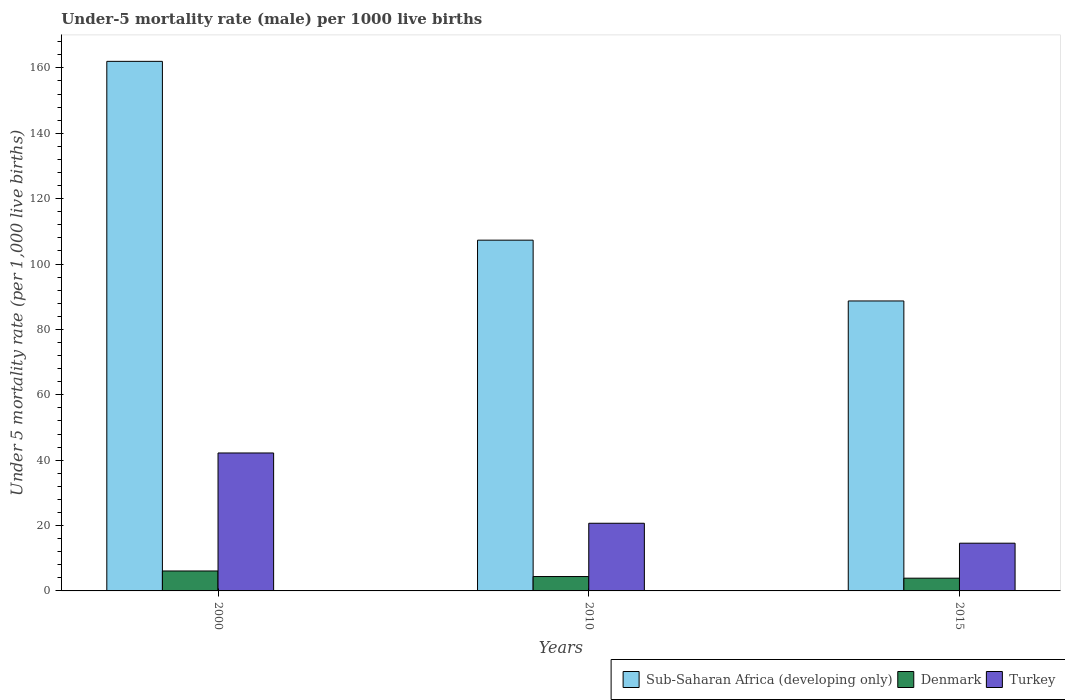How many different coloured bars are there?
Offer a very short reply. 3. How many groups of bars are there?
Provide a short and direct response. 3. Are the number of bars on each tick of the X-axis equal?
Provide a succinct answer. Yes. How many bars are there on the 3rd tick from the right?
Give a very brief answer. 3. Across all years, what is the maximum under-five mortality rate in Sub-Saharan Africa (developing only)?
Your response must be concise. 162. In which year was the under-five mortality rate in Sub-Saharan Africa (developing only) minimum?
Ensure brevity in your answer.  2015. What is the total under-five mortality rate in Sub-Saharan Africa (developing only) in the graph?
Make the answer very short. 358. What is the difference between the under-five mortality rate in Sub-Saharan Africa (developing only) in 2000 and that in 2010?
Make the answer very short. 54.7. What is the difference between the under-five mortality rate in Turkey in 2010 and the under-five mortality rate in Denmark in 2015?
Make the answer very short. 16.8. What is the average under-five mortality rate in Sub-Saharan Africa (developing only) per year?
Your answer should be compact. 119.33. In the year 2015, what is the difference between the under-five mortality rate in Denmark and under-five mortality rate in Turkey?
Your response must be concise. -10.7. In how many years, is the under-five mortality rate in Turkey greater than 160?
Your answer should be very brief. 0. What is the ratio of the under-five mortality rate in Turkey in 2010 to that in 2015?
Your answer should be very brief. 1.42. Is the under-five mortality rate in Turkey in 2000 less than that in 2010?
Keep it short and to the point. No. Is the difference between the under-five mortality rate in Denmark in 2000 and 2010 greater than the difference between the under-five mortality rate in Turkey in 2000 and 2010?
Keep it short and to the point. No. What is the difference between the highest and the second highest under-five mortality rate in Turkey?
Offer a very short reply. 21.5. What is the difference between the highest and the lowest under-five mortality rate in Denmark?
Make the answer very short. 2.2. Is the sum of the under-five mortality rate in Sub-Saharan Africa (developing only) in 2010 and 2015 greater than the maximum under-five mortality rate in Turkey across all years?
Your answer should be compact. Yes. What does the 1st bar from the left in 2015 represents?
Keep it short and to the point. Sub-Saharan Africa (developing only). Is it the case that in every year, the sum of the under-five mortality rate in Denmark and under-five mortality rate in Sub-Saharan Africa (developing only) is greater than the under-five mortality rate in Turkey?
Offer a terse response. Yes. How many bars are there?
Ensure brevity in your answer.  9. Are all the bars in the graph horizontal?
Ensure brevity in your answer.  No. What is the difference between two consecutive major ticks on the Y-axis?
Your response must be concise. 20. Are the values on the major ticks of Y-axis written in scientific E-notation?
Provide a short and direct response. No. Where does the legend appear in the graph?
Keep it short and to the point. Bottom right. How many legend labels are there?
Your answer should be compact. 3. What is the title of the graph?
Your answer should be compact. Under-5 mortality rate (male) per 1000 live births. What is the label or title of the Y-axis?
Ensure brevity in your answer.  Under 5 mortality rate (per 1,0 live births). What is the Under 5 mortality rate (per 1,000 live births) of Sub-Saharan Africa (developing only) in 2000?
Keep it short and to the point. 162. What is the Under 5 mortality rate (per 1,000 live births) in Denmark in 2000?
Keep it short and to the point. 6.1. What is the Under 5 mortality rate (per 1,000 live births) of Turkey in 2000?
Your answer should be compact. 42.2. What is the Under 5 mortality rate (per 1,000 live births) of Sub-Saharan Africa (developing only) in 2010?
Give a very brief answer. 107.3. What is the Under 5 mortality rate (per 1,000 live births) of Turkey in 2010?
Give a very brief answer. 20.7. What is the Under 5 mortality rate (per 1,000 live births) in Sub-Saharan Africa (developing only) in 2015?
Offer a terse response. 88.7. What is the Under 5 mortality rate (per 1,000 live births) in Turkey in 2015?
Provide a succinct answer. 14.6. Across all years, what is the maximum Under 5 mortality rate (per 1,000 live births) of Sub-Saharan Africa (developing only)?
Give a very brief answer. 162. Across all years, what is the maximum Under 5 mortality rate (per 1,000 live births) of Turkey?
Offer a very short reply. 42.2. Across all years, what is the minimum Under 5 mortality rate (per 1,000 live births) in Sub-Saharan Africa (developing only)?
Provide a succinct answer. 88.7. What is the total Under 5 mortality rate (per 1,000 live births) of Sub-Saharan Africa (developing only) in the graph?
Offer a terse response. 358. What is the total Under 5 mortality rate (per 1,000 live births) in Denmark in the graph?
Your response must be concise. 14.4. What is the total Under 5 mortality rate (per 1,000 live births) of Turkey in the graph?
Your answer should be very brief. 77.5. What is the difference between the Under 5 mortality rate (per 1,000 live births) in Sub-Saharan Africa (developing only) in 2000 and that in 2010?
Your answer should be very brief. 54.7. What is the difference between the Under 5 mortality rate (per 1,000 live births) of Denmark in 2000 and that in 2010?
Offer a very short reply. 1.7. What is the difference between the Under 5 mortality rate (per 1,000 live births) of Sub-Saharan Africa (developing only) in 2000 and that in 2015?
Make the answer very short. 73.3. What is the difference between the Under 5 mortality rate (per 1,000 live births) of Turkey in 2000 and that in 2015?
Offer a very short reply. 27.6. What is the difference between the Under 5 mortality rate (per 1,000 live births) of Sub-Saharan Africa (developing only) in 2010 and that in 2015?
Offer a terse response. 18.6. What is the difference between the Under 5 mortality rate (per 1,000 live births) in Denmark in 2010 and that in 2015?
Make the answer very short. 0.5. What is the difference between the Under 5 mortality rate (per 1,000 live births) in Turkey in 2010 and that in 2015?
Your answer should be compact. 6.1. What is the difference between the Under 5 mortality rate (per 1,000 live births) of Sub-Saharan Africa (developing only) in 2000 and the Under 5 mortality rate (per 1,000 live births) of Denmark in 2010?
Keep it short and to the point. 157.6. What is the difference between the Under 5 mortality rate (per 1,000 live births) in Sub-Saharan Africa (developing only) in 2000 and the Under 5 mortality rate (per 1,000 live births) in Turkey in 2010?
Your response must be concise. 141.3. What is the difference between the Under 5 mortality rate (per 1,000 live births) of Denmark in 2000 and the Under 5 mortality rate (per 1,000 live births) of Turkey in 2010?
Offer a terse response. -14.6. What is the difference between the Under 5 mortality rate (per 1,000 live births) in Sub-Saharan Africa (developing only) in 2000 and the Under 5 mortality rate (per 1,000 live births) in Denmark in 2015?
Your response must be concise. 158.1. What is the difference between the Under 5 mortality rate (per 1,000 live births) of Sub-Saharan Africa (developing only) in 2000 and the Under 5 mortality rate (per 1,000 live births) of Turkey in 2015?
Give a very brief answer. 147.4. What is the difference between the Under 5 mortality rate (per 1,000 live births) of Denmark in 2000 and the Under 5 mortality rate (per 1,000 live births) of Turkey in 2015?
Ensure brevity in your answer.  -8.5. What is the difference between the Under 5 mortality rate (per 1,000 live births) of Sub-Saharan Africa (developing only) in 2010 and the Under 5 mortality rate (per 1,000 live births) of Denmark in 2015?
Provide a succinct answer. 103.4. What is the difference between the Under 5 mortality rate (per 1,000 live births) in Sub-Saharan Africa (developing only) in 2010 and the Under 5 mortality rate (per 1,000 live births) in Turkey in 2015?
Ensure brevity in your answer.  92.7. What is the difference between the Under 5 mortality rate (per 1,000 live births) in Denmark in 2010 and the Under 5 mortality rate (per 1,000 live births) in Turkey in 2015?
Give a very brief answer. -10.2. What is the average Under 5 mortality rate (per 1,000 live births) in Sub-Saharan Africa (developing only) per year?
Offer a very short reply. 119.33. What is the average Under 5 mortality rate (per 1,000 live births) of Denmark per year?
Keep it short and to the point. 4.8. What is the average Under 5 mortality rate (per 1,000 live births) of Turkey per year?
Your answer should be very brief. 25.83. In the year 2000, what is the difference between the Under 5 mortality rate (per 1,000 live births) of Sub-Saharan Africa (developing only) and Under 5 mortality rate (per 1,000 live births) of Denmark?
Give a very brief answer. 155.9. In the year 2000, what is the difference between the Under 5 mortality rate (per 1,000 live births) of Sub-Saharan Africa (developing only) and Under 5 mortality rate (per 1,000 live births) of Turkey?
Provide a succinct answer. 119.8. In the year 2000, what is the difference between the Under 5 mortality rate (per 1,000 live births) in Denmark and Under 5 mortality rate (per 1,000 live births) in Turkey?
Ensure brevity in your answer.  -36.1. In the year 2010, what is the difference between the Under 5 mortality rate (per 1,000 live births) in Sub-Saharan Africa (developing only) and Under 5 mortality rate (per 1,000 live births) in Denmark?
Your answer should be compact. 102.9. In the year 2010, what is the difference between the Under 5 mortality rate (per 1,000 live births) in Sub-Saharan Africa (developing only) and Under 5 mortality rate (per 1,000 live births) in Turkey?
Your answer should be compact. 86.6. In the year 2010, what is the difference between the Under 5 mortality rate (per 1,000 live births) in Denmark and Under 5 mortality rate (per 1,000 live births) in Turkey?
Offer a very short reply. -16.3. In the year 2015, what is the difference between the Under 5 mortality rate (per 1,000 live births) of Sub-Saharan Africa (developing only) and Under 5 mortality rate (per 1,000 live births) of Denmark?
Your answer should be very brief. 84.8. In the year 2015, what is the difference between the Under 5 mortality rate (per 1,000 live births) of Sub-Saharan Africa (developing only) and Under 5 mortality rate (per 1,000 live births) of Turkey?
Your answer should be very brief. 74.1. In the year 2015, what is the difference between the Under 5 mortality rate (per 1,000 live births) of Denmark and Under 5 mortality rate (per 1,000 live births) of Turkey?
Your answer should be very brief. -10.7. What is the ratio of the Under 5 mortality rate (per 1,000 live births) in Sub-Saharan Africa (developing only) in 2000 to that in 2010?
Give a very brief answer. 1.51. What is the ratio of the Under 5 mortality rate (per 1,000 live births) in Denmark in 2000 to that in 2010?
Offer a terse response. 1.39. What is the ratio of the Under 5 mortality rate (per 1,000 live births) in Turkey in 2000 to that in 2010?
Keep it short and to the point. 2.04. What is the ratio of the Under 5 mortality rate (per 1,000 live births) of Sub-Saharan Africa (developing only) in 2000 to that in 2015?
Ensure brevity in your answer.  1.83. What is the ratio of the Under 5 mortality rate (per 1,000 live births) of Denmark in 2000 to that in 2015?
Provide a succinct answer. 1.56. What is the ratio of the Under 5 mortality rate (per 1,000 live births) in Turkey in 2000 to that in 2015?
Your answer should be compact. 2.89. What is the ratio of the Under 5 mortality rate (per 1,000 live births) in Sub-Saharan Africa (developing only) in 2010 to that in 2015?
Ensure brevity in your answer.  1.21. What is the ratio of the Under 5 mortality rate (per 1,000 live births) in Denmark in 2010 to that in 2015?
Your answer should be compact. 1.13. What is the ratio of the Under 5 mortality rate (per 1,000 live births) of Turkey in 2010 to that in 2015?
Your answer should be very brief. 1.42. What is the difference between the highest and the second highest Under 5 mortality rate (per 1,000 live births) of Sub-Saharan Africa (developing only)?
Your response must be concise. 54.7. What is the difference between the highest and the lowest Under 5 mortality rate (per 1,000 live births) in Sub-Saharan Africa (developing only)?
Offer a very short reply. 73.3. What is the difference between the highest and the lowest Under 5 mortality rate (per 1,000 live births) of Denmark?
Ensure brevity in your answer.  2.2. What is the difference between the highest and the lowest Under 5 mortality rate (per 1,000 live births) in Turkey?
Keep it short and to the point. 27.6. 